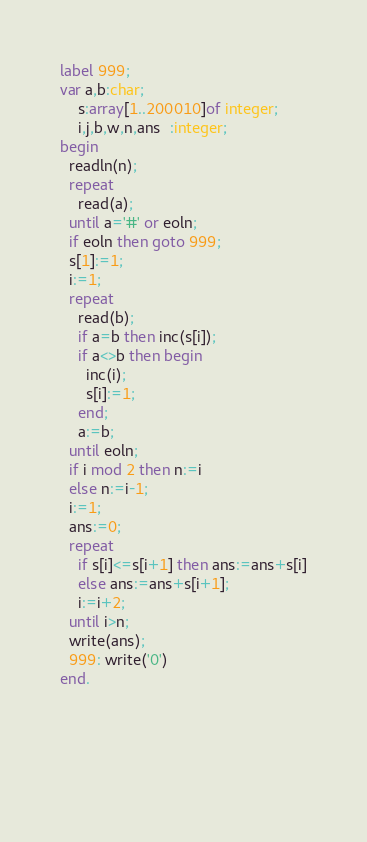<code> <loc_0><loc_0><loc_500><loc_500><_Pascal_>label 999;
var a,b:char;
    s:array[1..200010]of integer;
    i,j,b,w,n,ans  :integer;
begin
  readln(n);
  repeat
    read(a);
  until a='#' or eoln;
  if eoln then goto 999;
  s[1]:=1;
  i:=1;
  repeat
    read(b);
    if a=b then inc(s[i]);
    if a<>b then begin
      inc(i);
      s[i]:=1;
    end;
    a:=b;
  until eoln;
  if i mod 2 then n:=i
  else n:=i-1;
  i:=1;
  ans:=0;
  repeat
    if s[i]<=s[i+1] then ans:=ans+s[i]
    else ans:=ans+s[i+1];
    i:=i+2;
  until i>n;
  write(ans);
  999: write('0')
end.
  
    
    
    
      
</code> 